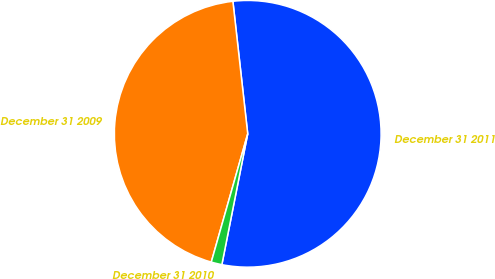<chart> <loc_0><loc_0><loc_500><loc_500><pie_chart><fcel>December 31 2011<fcel>December 31 2009<fcel>December 31 2010<nl><fcel>54.88%<fcel>43.82%<fcel>1.3%<nl></chart> 